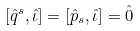Convert formula to latex. <formula><loc_0><loc_0><loc_500><loc_500>\left [ \hat { q } ^ { s } , \hat { \iota } \right ] = \left [ \hat { p } _ { s } , \hat { \iota } \right ] = \hat { 0 }</formula> 